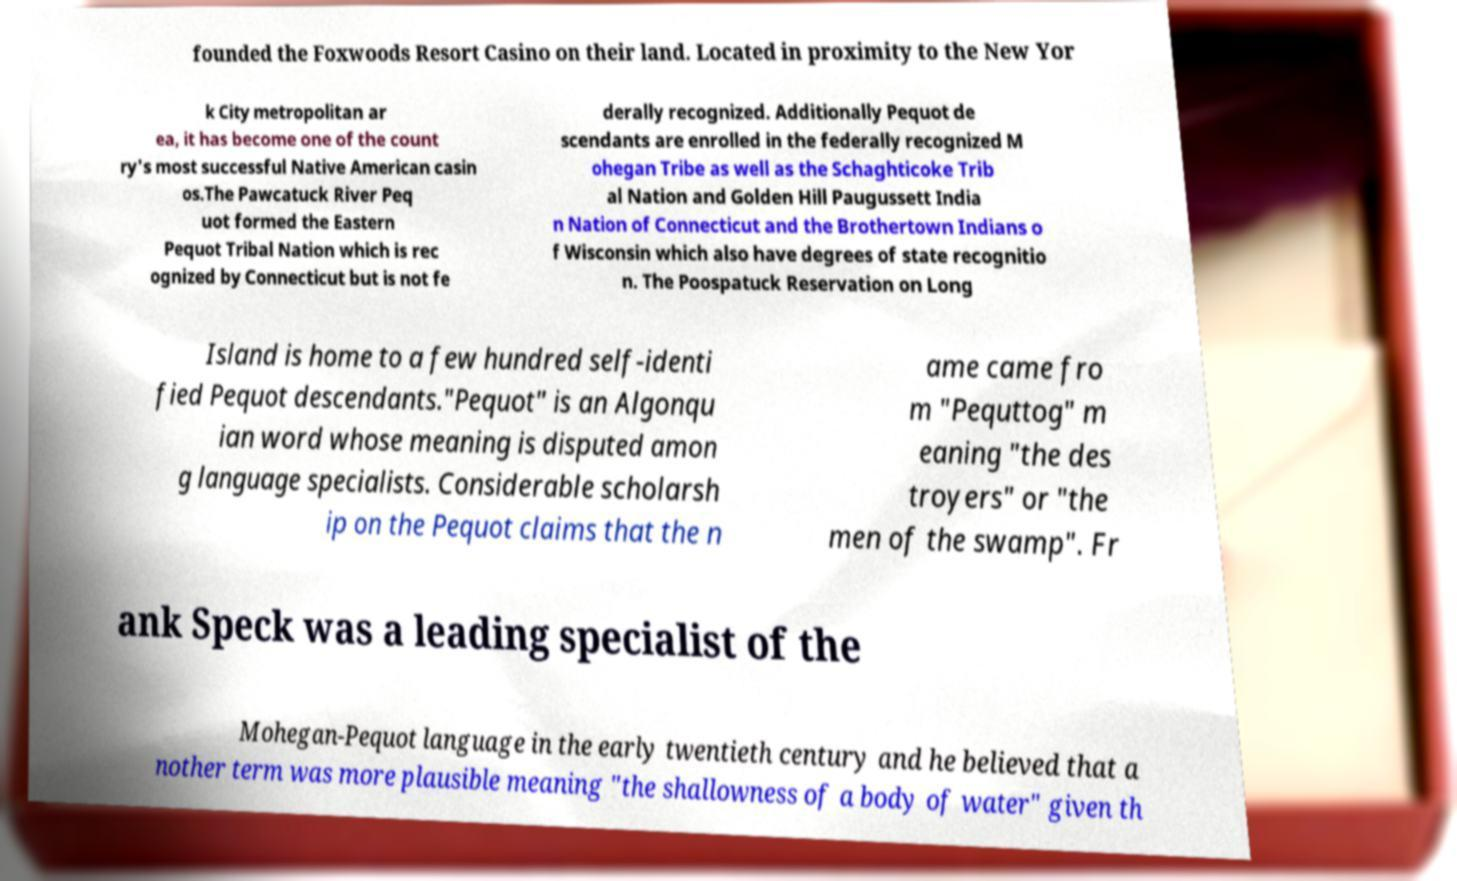Can you read and provide the text displayed in the image?This photo seems to have some interesting text. Can you extract and type it out for me? founded the Foxwoods Resort Casino on their land. Located in proximity to the New Yor k City metropolitan ar ea, it has become one of the count ry's most successful Native American casin os.The Pawcatuck River Peq uot formed the Eastern Pequot Tribal Nation which is rec ognized by Connecticut but is not fe derally recognized. Additionally Pequot de scendants are enrolled in the federally recognized M ohegan Tribe as well as the Schaghticoke Trib al Nation and Golden Hill Paugussett India n Nation of Connecticut and the Brothertown Indians o f Wisconsin which also have degrees of state recognitio n. The Poospatuck Reservation on Long Island is home to a few hundred self-identi fied Pequot descendants."Pequot" is an Algonqu ian word whose meaning is disputed amon g language specialists. Considerable scholarsh ip on the Pequot claims that the n ame came fro m "Pequttog" m eaning "the des troyers" or "the men of the swamp". Fr ank Speck was a leading specialist of the Mohegan-Pequot language in the early twentieth century and he believed that a nother term was more plausible meaning "the shallowness of a body of water" given th 